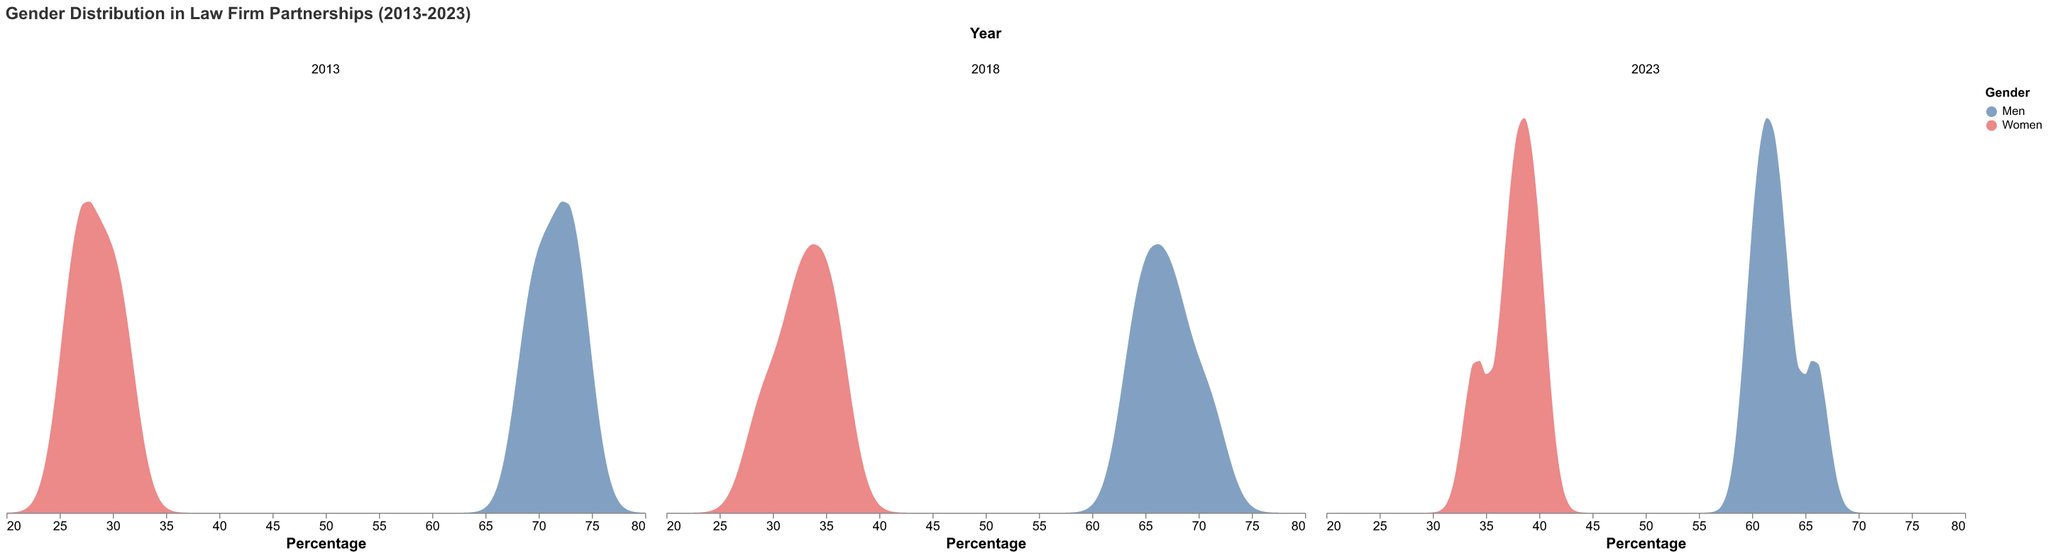What is the title of the plot? The title of the plot is located at the top, it reads: "Gender Distribution in Law Firm Partnerships (2013-2023)".
Answer: Gender Distribution in Law Firm Partnerships (2013-2023) Which color represents women in the plot? The colors representing genders are indicated in the legend, next to "Gender". The color for women is a shade of red.
Answer: Red In which year did Baker McKenzie have the highest percentage of women partners? By looking at Baker McKenzie's data points across the years, 2023 shows the highest percentage for women at 40%.
Answer: 2023 How did the percentage of men partners at Clifford Chance change from 2013 to 2023? By looking at the data points for Clifford Chance: in 2013, men represented 72%, and by 2023 this had decreased to 63%. The change is a decrease of 9%.
Answer: Decreased by 9% What is the difference in the percentage of women partners in Allen & Overy between 2018 and 2023? For Allen & Overy, the percentage of women in 2018 was 29% and in 2023 it was 34%. The difference is 34% - 29% = 5%.
Answer: 5% In which firm and year did women partners make up 39% of the partnerships? Checking the data for each firm and year, Linklaters in 2023 is the only instance where women partners are at 39%.
Answer: Linklaters, 2023 Which firm showed the largest increase in the percentage of women partners from 2013 to 2023? By comparing the differences in percentages for women partners across all firms from 2013 to 2023: Baker McKenzie increased from 30% to 40%, which is a 10% increase, the largest among all.
Answer: Baker McKenzie Did any firm have a year where the percentage of women partners was above 35%? If yes, name the firm and the year. Reviewing the data, Baker McKenzie in 2023 (40%), Clifford Chance in 2023 (37%), Linklaters in 2018 (36%), Linklaters in 2023 (39%), and Latham & Watkins in 2023 (38%) all had women partners above 35%.
Answer: Multiple firms and years Describe the trend for men partners at Latham & Watkins across the three years. The men's percentage at Latham & Watkins shows a consistent decrease: 73% in 2013, 67% in 2018, and 62% in 2023. This indicates a declining trend over the years.
Answer: Declining trend 